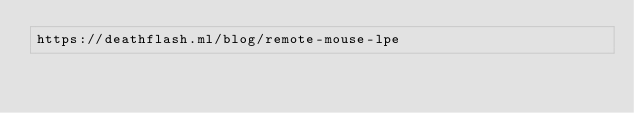<code> <loc_0><loc_0><loc_500><loc_500><_OCaml_>https://deathflash.ml/blog/remote-mouse-lpe
</code> 